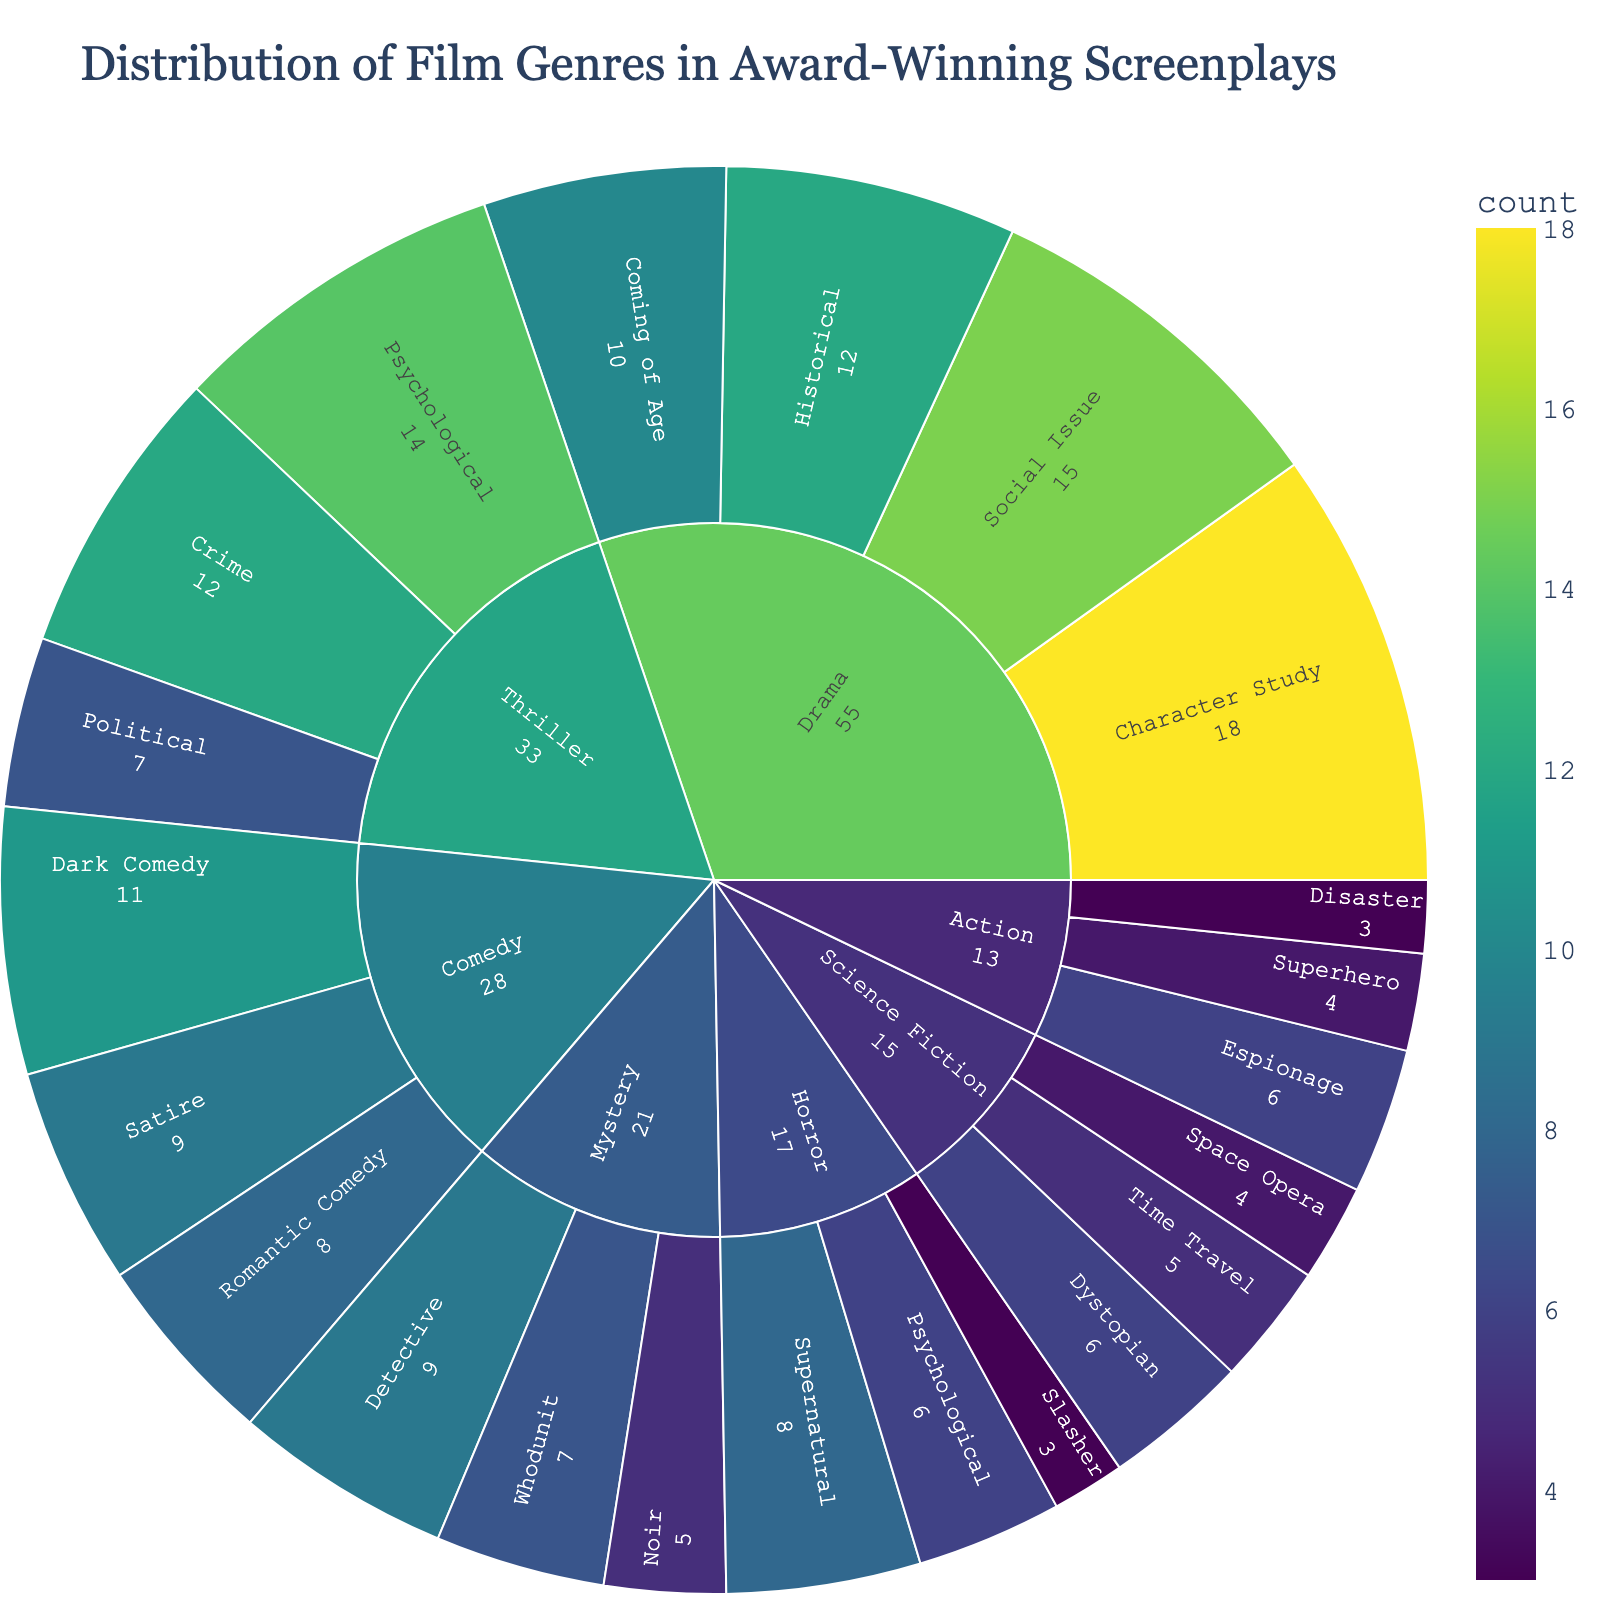How many award-winning screenplays belong to the "Drama" genre? Locate the "Drama" section and sum all the sub-genre counts. Drama (Character Study: 18) + Drama (Historical: 12) + Drama (Coming of Age: 10) + Drama (Social Issue: 15). So, 18 + 12 + 10 + 15 = 55
Answer: 55 Which sub-genre under "Thriller" has the least number of award-winning screenplays? Locate the "Thriller" section and compare counts of its sub-genres: Psychological (14), Crime (12), and Political (7). The least is 7 under Political.
Answer: Political What is the total number of award-winning screenplays in the "Comedy" genre? Locate the "Comedy" section and sum all the sub-genre counts. Comedy (Romantic Comedy: 8) + Comedy (Dark Comedy: 11) + Comedy (Satire: 9). So, 8 + 11 + 9 = 28
Answer: 28 Which sub-genre has the highest count across all genres? Look for the sub-genre with the highest value. Character Study under Drama has 18, which is the highest among all.
Answer: Character Study How does the count of "Psychological Thriller" compare to "Psychological Horror"? Locate both sub-genres' counts: Psychological Thriller (14) and Psychological Horror (6). Compare the two values directly; 14 is greater than 6.
Answer: Psychological Thriller is greater What is the difference in count between "Superhero" and "Space Opera" sub-genres? Locate the counts for Superhero (4) and Space Opera (4). The difference is 4 - 4 = 0.
Answer: 0 Which sub-genre has more award-winning screenplays: "Detective" or "Whodunit"? Locate the sub-genre counts: Detective (9) and Whodunit (7). Detective is more.
Answer: Detective What proportion of award-winning screenplays are in the "Horror" genre? Calculate the total count for all scripts: 55 + 28 + 33 + 15 + 18 + 21 + 6 + 7 = 183. Total for Horror is 8 + 6 + 3 = 17. Proportion is 17 / 183.
Answer: 17/183 What is the median count of award-winning screenplays in the sub-genres of "Mystery"? Counts are: Detective (9), Whodunit (7), Noir (5). Median of (9, 7, 5) is 7.
Answer: 7 